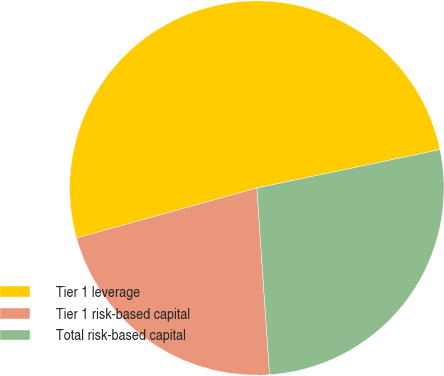Convert chart. <chart><loc_0><loc_0><loc_500><loc_500><pie_chart><fcel>Tier 1 leverage<fcel>Tier 1 risk-based capital<fcel>Total risk-based capital<nl><fcel>51.02%<fcel>21.78%<fcel>27.21%<nl></chart> 